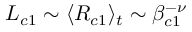Convert formula to latex. <formula><loc_0><loc_0><loc_500><loc_500>L _ { c 1 } \sim \langle R _ { c 1 } \rangle _ { t } \sim \beta _ { c 1 } ^ { - \nu }</formula> 